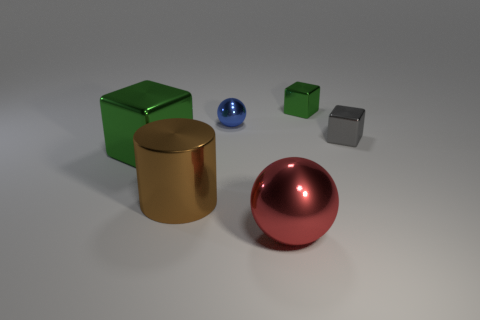Add 3 cyan rubber spheres. How many objects exist? 9 Subtract all cylinders. How many objects are left? 5 Subtract 1 gray cubes. How many objects are left? 5 Subtract all yellow matte things. Subtract all large shiny spheres. How many objects are left? 5 Add 5 small objects. How many small objects are left? 8 Add 3 tiny green shiny objects. How many tiny green shiny objects exist? 4 